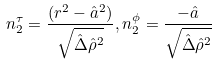Convert formula to latex. <formula><loc_0><loc_0><loc_500><loc_500>n _ { 2 } ^ { \tau } = \frac { ( r ^ { 2 } - \hat { a } ^ { 2 } ) } { \sqrt { \hat { \Delta } \hat { \rho } ^ { 2 } } } , n _ { 2 } ^ { \phi } = \frac { - \hat { a } } { \sqrt { \hat { \Delta } \hat { \rho } ^ { 2 } } }</formula> 